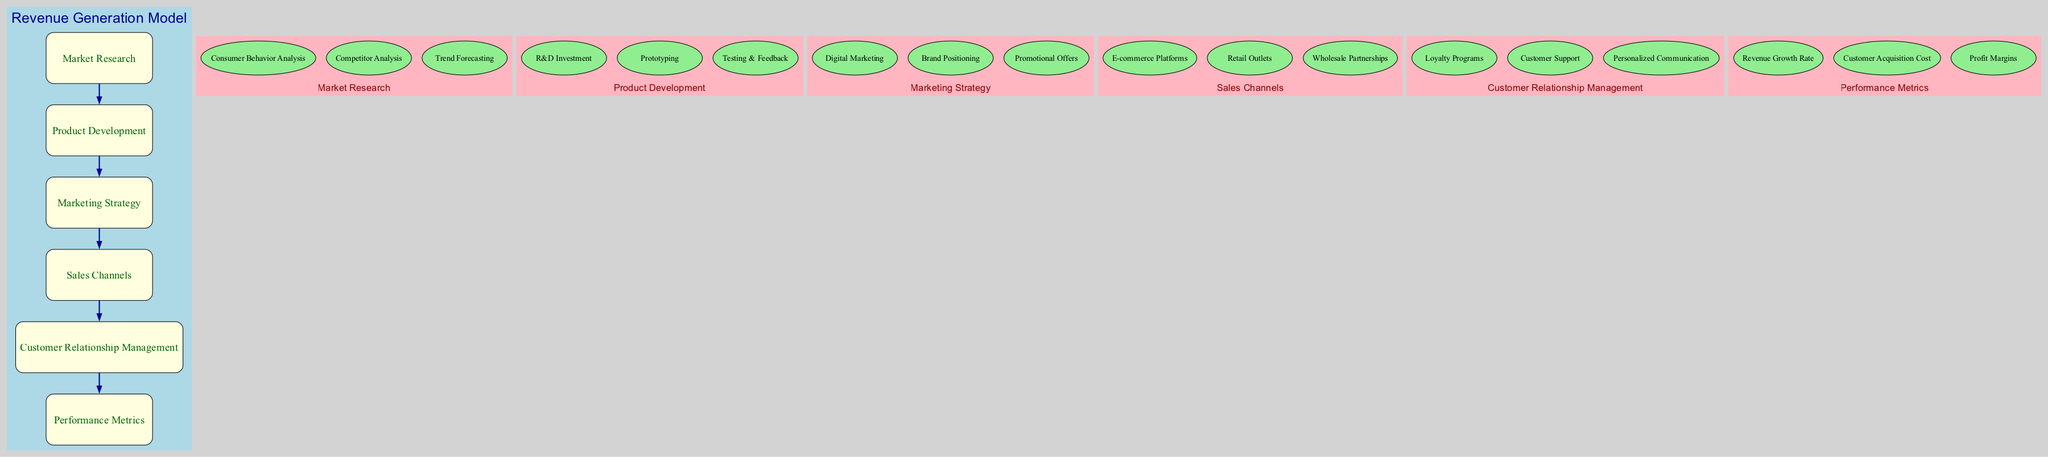What is the main focus of the "Market Research" element? The "Market Research" element focuses on collecting and analyzing data to identify current and future market trends, including technologies and consumer preferences.
Answer: Collect and analyze data How many sub-elements are there in "Product Development"? The "Product Development" element lists three sub-elements: R&D Investment, Prototyping, and Testing & Feedback. Counting these provides the answer.
Answer: 3 What is the description of "Customer Relationship Management"? The description for "Customer Relationship Management" states that it aims to build and maintain strong customer relationships for repeat business, ensuring continued customer engagement and retention.
Answer: Build and maintain strong customer relationships Which two nodes are connected directly by an edge? The diagram connects several nodes sequentially, and by tracing the edges, I find that "Market Research" directly connects to "Product Development". This direct line indicates the relationship between these elements.
Answer: Market Research and Product Development What are the three sub-elements under "Sales Channels"? The "Sales Channels" element includes three sub-components: E-commerce Platforms, Retail Outlets, and Wholesale Partnerships that illustrate various methods for distribution and maximizing sales.
Answer: E-commerce Platforms, Retail Outlets, Wholesale Partnerships Which element monitors "Revenue Growth Rate"? The "Performance Metrics" element is responsible for monitoring key performance indicators like the Revenue Growth Rate, which helps assess business success over time.
Answer: Performance Metrics How many main elements are shown in the diagram? The diagram features a total of six main elements by counting each of the distinct boxes labeled: Market Research, Product Development, Marketing Strategy, Sales Channels, Customer Relationship Management, and Performance Metrics.
Answer: 6 